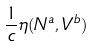Convert formula to latex. <formula><loc_0><loc_0><loc_500><loc_500>\frac { 1 } { c } \eta ( N ^ { a } , V ^ { b } )</formula> 